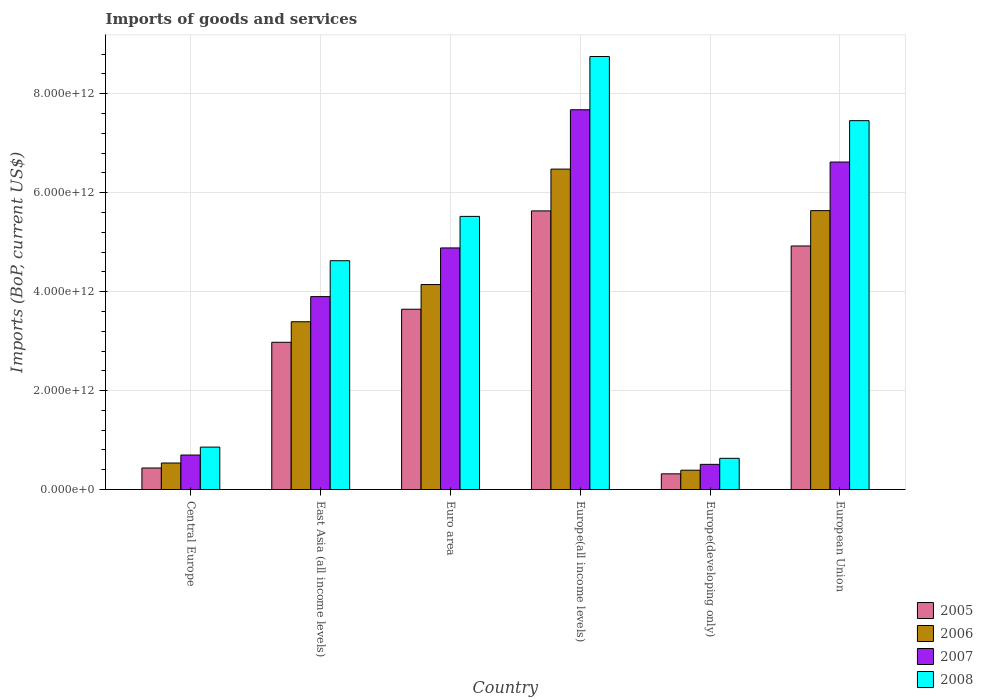How many different coloured bars are there?
Offer a very short reply. 4. How many groups of bars are there?
Your answer should be very brief. 6. Are the number of bars on each tick of the X-axis equal?
Your answer should be very brief. Yes. How many bars are there on the 5th tick from the right?
Offer a very short reply. 4. What is the label of the 2nd group of bars from the left?
Your response must be concise. East Asia (all income levels). In how many cases, is the number of bars for a given country not equal to the number of legend labels?
Keep it short and to the point. 0. What is the amount spent on imports in 2007 in Central Europe?
Provide a short and direct response. 6.97e+11. Across all countries, what is the maximum amount spent on imports in 2006?
Your answer should be very brief. 6.48e+12. Across all countries, what is the minimum amount spent on imports in 2007?
Your response must be concise. 5.09e+11. In which country was the amount spent on imports in 2008 maximum?
Keep it short and to the point. Europe(all income levels). In which country was the amount spent on imports in 2007 minimum?
Your response must be concise. Europe(developing only). What is the total amount spent on imports in 2008 in the graph?
Your answer should be compact. 2.78e+13. What is the difference between the amount spent on imports in 2007 in Europe(developing only) and that in European Union?
Make the answer very short. -6.11e+12. What is the difference between the amount spent on imports in 2008 in Europe(all income levels) and the amount spent on imports in 2005 in Euro area?
Provide a short and direct response. 5.11e+12. What is the average amount spent on imports in 2007 per country?
Offer a terse response. 4.05e+12. What is the difference between the amount spent on imports of/in 2008 and amount spent on imports of/in 2005 in Euro area?
Provide a short and direct response. 1.88e+12. In how many countries, is the amount spent on imports in 2008 greater than 4400000000000 US$?
Provide a short and direct response. 4. What is the ratio of the amount spent on imports in 2007 in East Asia (all income levels) to that in European Union?
Your answer should be very brief. 0.59. Is the amount spent on imports in 2006 in East Asia (all income levels) less than that in Europe(all income levels)?
Your answer should be compact. Yes. Is the difference between the amount spent on imports in 2008 in Euro area and Europe(developing only) greater than the difference between the amount spent on imports in 2005 in Euro area and Europe(developing only)?
Your answer should be compact. Yes. What is the difference between the highest and the second highest amount spent on imports in 2008?
Your answer should be very brief. -1.94e+12. What is the difference between the highest and the lowest amount spent on imports in 2007?
Keep it short and to the point. 7.17e+12. In how many countries, is the amount spent on imports in 2006 greater than the average amount spent on imports in 2006 taken over all countries?
Offer a very short reply. 3. Is the sum of the amount spent on imports in 2007 in Central Europe and Euro area greater than the maximum amount spent on imports in 2008 across all countries?
Make the answer very short. No. Is it the case that in every country, the sum of the amount spent on imports in 2005 and amount spent on imports in 2006 is greater than the sum of amount spent on imports in 2008 and amount spent on imports in 2007?
Offer a terse response. No. Is it the case that in every country, the sum of the amount spent on imports in 2008 and amount spent on imports in 2007 is greater than the amount spent on imports in 2006?
Ensure brevity in your answer.  Yes. What is the difference between two consecutive major ticks on the Y-axis?
Make the answer very short. 2.00e+12. Are the values on the major ticks of Y-axis written in scientific E-notation?
Make the answer very short. Yes. Does the graph contain any zero values?
Provide a succinct answer. No. Does the graph contain grids?
Offer a terse response. Yes. What is the title of the graph?
Offer a very short reply. Imports of goods and services. Does "1987" appear as one of the legend labels in the graph?
Keep it short and to the point. No. What is the label or title of the X-axis?
Offer a very short reply. Country. What is the label or title of the Y-axis?
Provide a succinct answer. Imports (BoP, current US$). What is the Imports (BoP, current US$) of 2005 in Central Europe?
Your answer should be very brief. 4.35e+11. What is the Imports (BoP, current US$) of 2006 in Central Europe?
Provide a succinct answer. 5.36e+11. What is the Imports (BoP, current US$) in 2007 in Central Europe?
Offer a very short reply. 6.97e+11. What is the Imports (BoP, current US$) of 2008 in Central Europe?
Ensure brevity in your answer.  8.57e+11. What is the Imports (BoP, current US$) of 2005 in East Asia (all income levels)?
Provide a short and direct response. 2.98e+12. What is the Imports (BoP, current US$) of 2006 in East Asia (all income levels)?
Provide a short and direct response. 3.39e+12. What is the Imports (BoP, current US$) of 2007 in East Asia (all income levels)?
Your response must be concise. 3.90e+12. What is the Imports (BoP, current US$) of 2008 in East Asia (all income levels)?
Ensure brevity in your answer.  4.63e+12. What is the Imports (BoP, current US$) in 2005 in Euro area?
Your response must be concise. 3.64e+12. What is the Imports (BoP, current US$) of 2006 in Euro area?
Offer a terse response. 4.14e+12. What is the Imports (BoP, current US$) in 2007 in Euro area?
Provide a succinct answer. 4.88e+12. What is the Imports (BoP, current US$) of 2008 in Euro area?
Ensure brevity in your answer.  5.52e+12. What is the Imports (BoP, current US$) in 2005 in Europe(all income levels)?
Keep it short and to the point. 5.63e+12. What is the Imports (BoP, current US$) in 2006 in Europe(all income levels)?
Offer a terse response. 6.48e+12. What is the Imports (BoP, current US$) in 2007 in Europe(all income levels)?
Keep it short and to the point. 7.68e+12. What is the Imports (BoP, current US$) of 2008 in Europe(all income levels)?
Ensure brevity in your answer.  8.75e+12. What is the Imports (BoP, current US$) of 2005 in Europe(developing only)?
Ensure brevity in your answer.  3.17e+11. What is the Imports (BoP, current US$) of 2006 in Europe(developing only)?
Provide a succinct answer. 3.90e+11. What is the Imports (BoP, current US$) of 2007 in Europe(developing only)?
Your answer should be compact. 5.09e+11. What is the Imports (BoP, current US$) of 2008 in Europe(developing only)?
Offer a terse response. 6.31e+11. What is the Imports (BoP, current US$) in 2005 in European Union?
Provide a short and direct response. 4.92e+12. What is the Imports (BoP, current US$) of 2006 in European Union?
Your response must be concise. 5.64e+12. What is the Imports (BoP, current US$) in 2007 in European Union?
Your answer should be compact. 6.62e+12. What is the Imports (BoP, current US$) in 2008 in European Union?
Give a very brief answer. 7.46e+12. Across all countries, what is the maximum Imports (BoP, current US$) in 2005?
Give a very brief answer. 5.63e+12. Across all countries, what is the maximum Imports (BoP, current US$) in 2006?
Keep it short and to the point. 6.48e+12. Across all countries, what is the maximum Imports (BoP, current US$) in 2007?
Offer a terse response. 7.68e+12. Across all countries, what is the maximum Imports (BoP, current US$) in 2008?
Make the answer very short. 8.75e+12. Across all countries, what is the minimum Imports (BoP, current US$) of 2005?
Ensure brevity in your answer.  3.17e+11. Across all countries, what is the minimum Imports (BoP, current US$) in 2006?
Offer a very short reply. 3.90e+11. Across all countries, what is the minimum Imports (BoP, current US$) in 2007?
Keep it short and to the point. 5.09e+11. Across all countries, what is the minimum Imports (BoP, current US$) of 2008?
Make the answer very short. 6.31e+11. What is the total Imports (BoP, current US$) in 2005 in the graph?
Provide a succinct answer. 1.79e+13. What is the total Imports (BoP, current US$) of 2006 in the graph?
Offer a very short reply. 2.06e+13. What is the total Imports (BoP, current US$) in 2007 in the graph?
Offer a terse response. 2.43e+13. What is the total Imports (BoP, current US$) in 2008 in the graph?
Ensure brevity in your answer.  2.78e+13. What is the difference between the Imports (BoP, current US$) in 2005 in Central Europe and that in East Asia (all income levels)?
Keep it short and to the point. -2.54e+12. What is the difference between the Imports (BoP, current US$) of 2006 in Central Europe and that in East Asia (all income levels)?
Ensure brevity in your answer.  -2.86e+12. What is the difference between the Imports (BoP, current US$) of 2007 in Central Europe and that in East Asia (all income levels)?
Offer a terse response. -3.20e+12. What is the difference between the Imports (BoP, current US$) in 2008 in Central Europe and that in East Asia (all income levels)?
Your answer should be compact. -3.77e+12. What is the difference between the Imports (BoP, current US$) of 2005 in Central Europe and that in Euro area?
Give a very brief answer. -3.21e+12. What is the difference between the Imports (BoP, current US$) in 2006 in Central Europe and that in Euro area?
Provide a short and direct response. -3.61e+12. What is the difference between the Imports (BoP, current US$) in 2007 in Central Europe and that in Euro area?
Offer a very short reply. -4.19e+12. What is the difference between the Imports (BoP, current US$) of 2008 in Central Europe and that in Euro area?
Your answer should be compact. -4.66e+12. What is the difference between the Imports (BoP, current US$) of 2005 in Central Europe and that in Europe(all income levels)?
Give a very brief answer. -5.20e+12. What is the difference between the Imports (BoP, current US$) in 2006 in Central Europe and that in Europe(all income levels)?
Give a very brief answer. -5.94e+12. What is the difference between the Imports (BoP, current US$) in 2007 in Central Europe and that in Europe(all income levels)?
Offer a very short reply. -6.98e+12. What is the difference between the Imports (BoP, current US$) in 2008 in Central Europe and that in Europe(all income levels)?
Offer a terse response. -7.90e+12. What is the difference between the Imports (BoP, current US$) of 2005 in Central Europe and that in Europe(developing only)?
Make the answer very short. 1.18e+11. What is the difference between the Imports (BoP, current US$) of 2006 in Central Europe and that in Europe(developing only)?
Your answer should be compact. 1.46e+11. What is the difference between the Imports (BoP, current US$) in 2007 in Central Europe and that in Europe(developing only)?
Your response must be concise. 1.88e+11. What is the difference between the Imports (BoP, current US$) of 2008 in Central Europe and that in Europe(developing only)?
Your response must be concise. 2.27e+11. What is the difference between the Imports (BoP, current US$) in 2005 in Central Europe and that in European Union?
Your answer should be very brief. -4.49e+12. What is the difference between the Imports (BoP, current US$) in 2006 in Central Europe and that in European Union?
Ensure brevity in your answer.  -5.10e+12. What is the difference between the Imports (BoP, current US$) in 2007 in Central Europe and that in European Union?
Your answer should be compact. -5.92e+12. What is the difference between the Imports (BoP, current US$) of 2008 in Central Europe and that in European Union?
Provide a succinct answer. -6.60e+12. What is the difference between the Imports (BoP, current US$) of 2005 in East Asia (all income levels) and that in Euro area?
Make the answer very short. -6.68e+11. What is the difference between the Imports (BoP, current US$) in 2006 in East Asia (all income levels) and that in Euro area?
Your answer should be compact. -7.52e+11. What is the difference between the Imports (BoP, current US$) of 2007 in East Asia (all income levels) and that in Euro area?
Keep it short and to the point. -9.84e+11. What is the difference between the Imports (BoP, current US$) of 2008 in East Asia (all income levels) and that in Euro area?
Ensure brevity in your answer.  -8.96e+11. What is the difference between the Imports (BoP, current US$) of 2005 in East Asia (all income levels) and that in Europe(all income levels)?
Ensure brevity in your answer.  -2.66e+12. What is the difference between the Imports (BoP, current US$) in 2006 in East Asia (all income levels) and that in Europe(all income levels)?
Make the answer very short. -3.09e+12. What is the difference between the Imports (BoP, current US$) in 2007 in East Asia (all income levels) and that in Europe(all income levels)?
Your response must be concise. -3.78e+12. What is the difference between the Imports (BoP, current US$) of 2008 in East Asia (all income levels) and that in Europe(all income levels)?
Give a very brief answer. -4.13e+12. What is the difference between the Imports (BoP, current US$) of 2005 in East Asia (all income levels) and that in Europe(developing only)?
Give a very brief answer. 2.66e+12. What is the difference between the Imports (BoP, current US$) of 2006 in East Asia (all income levels) and that in Europe(developing only)?
Provide a succinct answer. 3.00e+12. What is the difference between the Imports (BoP, current US$) in 2007 in East Asia (all income levels) and that in Europe(developing only)?
Your answer should be very brief. 3.39e+12. What is the difference between the Imports (BoP, current US$) of 2008 in East Asia (all income levels) and that in Europe(developing only)?
Provide a succinct answer. 3.99e+12. What is the difference between the Imports (BoP, current US$) in 2005 in East Asia (all income levels) and that in European Union?
Offer a very short reply. -1.95e+12. What is the difference between the Imports (BoP, current US$) of 2006 in East Asia (all income levels) and that in European Union?
Offer a terse response. -2.25e+12. What is the difference between the Imports (BoP, current US$) of 2007 in East Asia (all income levels) and that in European Union?
Offer a very short reply. -2.72e+12. What is the difference between the Imports (BoP, current US$) of 2008 in East Asia (all income levels) and that in European Union?
Your answer should be compact. -2.83e+12. What is the difference between the Imports (BoP, current US$) in 2005 in Euro area and that in Europe(all income levels)?
Keep it short and to the point. -1.99e+12. What is the difference between the Imports (BoP, current US$) in 2006 in Euro area and that in Europe(all income levels)?
Provide a succinct answer. -2.33e+12. What is the difference between the Imports (BoP, current US$) in 2007 in Euro area and that in Europe(all income levels)?
Your answer should be very brief. -2.79e+12. What is the difference between the Imports (BoP, current US$) of 2008 in Euro area and that in Europe(all income levels)?
Your answer should be very brief. -3.23e+12. What is the difference between the Imports (BoP, current US$) in 2005 in Euro area and that in Europe(developing only)?
Offer a very short reply. 3.33e+12. What is the difference between the Imports (BoP, current US$) in 2006 in Euro area and that in Europe(developing only)?
Give a very brief answer. 3.75e+12. What is the difference between the Imports (BoP, current US$) in 2007 in Euro area and that in Europe(developing only)?
Provide a short and direct response. 4.38e+12. What is the difference between the Imports (BoP, current US$) of 2008 in Euro area and that in Europe(developing only)?
Your answer should be very brief. 4.89e+12. What is the difference between the Imports (BoP, current US$) of 2005 in Euro area and that in European Union?
Make the answer very short. -1.28e+12. What is the difference between the Imports (BoP, current US$) in 2006 in Euro area and that in European Union?
Provide a short and direct response. -1.49e+12. What is the difference between the Imports (BoP, current US$) in 2007 in Euro area and that in European Union?
Offer a very short reply. -1.74e+12. What is the difference between the Imports (BoP, current US$) of 2008 in Euro area and that in European Union?
Give a very brief answer. -1.94e+12. What is the difference between the Imports (BoP, current US$) of 2005 in Europe(all income levels) and that in Europe(developing only)?
Your answer should be compact. 5.32e+12. What is the difference between the Imports (BoP, current US$) of 2006 in Europe(all income levels) and that in Europe(developing only)?
Provide a succinct answer. 6.09e+12. What is the difference between the Imports (BoP, current US$) of 2007 in Europe(all income levels) and that in Europe(developing only)?
Your answer should be very brief. 7.17e+12. What is the difference between the Imports (BoP, current US$) of 2008 in Europe(all income levels) and that in Europe(developing only)?
Ensure brevity in your answer.  8.12e+12. What is the difference between the Imports (BoP, current US$) in 2005 in Europe(all income levels) and that in European Union?
Ensure brevity in your answer.  7.09e+11. What is the difference between the Imports (BoP, current US$) in 2006 in Europe(all income levels) and that in European Union?
Keep it short and to the point. 8.39e+11. What is the difference between the Imports (BoP, current US$) of 2007 in Europe(all income levels) and that in European Union?
Your answer should be very brief. 1.06e+12. What is the difference between the Imports (BoP, current US$) of 2008 in Europe(all income levels) and that in European Union?
Give a very brief answer. 1.30e+12. What is the difference between the Imports (BoP, current US$) of 2005 in Europe(developing only) and that in European Union?
Give a very brief answer. -4.61e+12. What is the difference between the Imports (BoP, current US$) in 2006 in Europe(developing only) and that in European Union?
Give a very brief answer. -5.25e+12. What is the difference between the Imports (BoP, current US$) in 2007 in Europe(developing only) and that in European Union?
Offer a very short reply. -6.11e+12. What is the difference between the Imports (BoP, current US$) of 2008 in Europe(developing only) and that in European Union?
Give a very brief answer. -6.83e+12. What is the difference between the Imports (BoP, current US$) of 2005 in Central Europe and the Imports (BoP, current US$) of 2006 in East Asia (all income levels)?
Ensure brevity in your answer.  -2.96e+12. What is the difference between the Imports (BoP, current US$) of 2005 in Central Europe and the Imports (BoP, current US$) of 2007 in East Asia (all income levels)?
Ensure brevity in your answer.  -3.46e+12. What is the difference between the Imports (BoP, current US$) of 2005 in Central Europe and the Imports (BoP, current US$) of 2008 in East Asia (all income levels)?
Keep it short and to the point. -4.19e+12. What is the difference between the Imports (BoP, current US$) of 2006 in Central Europe and the Imports (BoP, current US$) of 2007 in East Asia (all income levels)?
Give a very brief answer. -3.36e+12. What is the difference between the Imports (BoP, current US$) in 2006 in Central Europe and the Imports (BoP, current US$) in 2008 in East Asia (all income levels)?
Your answer should be very brief. -4.09e+12. What is the difference between the Imports (BoP, current US$) of 2007 in Central Europe and the Imports (BoP, current US$) of 2008 in East Asia (all income levels)?
Offer a terse response. -3.93e+12. What is the difference between the Imports (BoP, current US$) of 2005 in Central Europe and the Imports (BoP, current US$) of 2006 in Euro area?
Offer a very short reply. -3.71e+12. What is the difference between the Imports (BoP, current US$) in 2005 in Central Europe and the Imports (BoP, current US$) in 2007 in Euro area?
Offer a terse response. -4.45e+12. What is the difference between the Imports (BoP, current US$) of 2005 in Central Europe and the Imports (BoP, current US$) of 2008 in Euro area?
Offer a very short reply. -5.09e+12. What is the difference between the Imports (BoP, current US$) in 2006 in Central Europe and the Imports (BoP, current US$) in 2007 in Euro area?
Ensure brevity in your answer.  -4.35e+12. What is the difference between the Imports (BoP, current US$) in 2006 in Central Europe and the Imports (BoP, current US$) in 2008 in Euro area?
Your response must be concise. -4.99e+12. What is the difference between the Imports (BoP, current US$) in 2007 in Central Europe and the Imports (BoP, current US$) in 2008 in Euro area?
Your response must be concise. -4.82e+12. What is the difference between the Imports (BoP, current US$) in 2005 in Central Europe and the Imports (BoP, current US$) in 2006 in Europe(all income levels)?
Provide a succinct answer. -6.04e+12. What is the difference between the Imports (BoP, current US$) of 2005 in Central Europe and the Imports (BoP, current US$) of 2007 in Europe(all income levels)?
Make the answer very short. -7.24e+12. What is the difference between the Imports (BoP, current US$) in 2005 in Central Europe and the Imports (BoP, current US$) in 2008 in Europe(all income levels)?
Provide a short and direct response. -8.32e+12. What is the difference between the Imports (BoP, current US$) of 2006 in Central Europe and the Imports (BoP, current US$) of 2007 in Europe(all income levels)?
Offer a very short reply. -7.14e+12. What is the difference between the Imports (BoP, current US$) of 2006 in Central Europe and the Imports (BoP, current US$) of 2008 in Europe(all income levels)?
Provide a short and direct response. -8.22e+12. What is the difference between the Imports (BoP, current US$) of 2007 in Central Europe and the Imports (BoP, current US$) of 2008 in Europe(all income levels)?
Your response must be concise. -8.06e+12. What is the difference between the Imports (BoP, current US$) of 2005 in Central Europe and the Imports (BoP, current US$) of 2006 in Europe(developing only)?
Your response must be concise. 4.49e+1. What is the difference between the Imports (BoP, current US$) in 2005 in Central Europe and the Imports (BoP, current US$) in 2007 in Europe(developing only)?
Provide a short and direct response. -7.36e+1. What is the difference between the Imports (BoP, current US$) of 2005 in Central Europe and the Imports (BoP, current US$) of 2008 in Europe(developing only)?
Make the answer very short. -1.95e+11. What is the difference between the Imports (BoP, current US$) in 2006 in Central Europe and the Imports (BoP, current US$) in 2007 in Europe(developing only)?
Make the answer very short. 2.70e+1. What is the difference between the Imports (BoP, current US$) in 2006 in Central Europe and the Imports (BoP, current US$) in 2008 in Europe(developing only)?
Your answer should be very brief. -9.48e+1. What is the difference between the Imports (BoP, current US$) in 2007 in Central Europe and the Imports (BoP, current US$) in 2008 in Europe(developing only)?
Offer a terse response. 6.65e+1. What is the difference between the Imports (BoP, current US$) in 2005 in Central Europe and the Imports (BoP, current US$) in 2006 in European Union?
Provide a succinct answer. -5.20e+12. What is the difference between the Imports (BoP, current US$) of 2005 in Central Europe and the Imports (BoP, current US$) of 2007 in European Union?
Ensure brevity in your answer.  -6.18e+12. What is the difference between the Imports (BoP, current US$) of 2005 in Central Europe and the Imports (BoP, current US$) of 2008 in European Union?
Keep it short and to the point. -7.02e+12. What is the difference between the Imports (BoP, current US$) of 2006 in Central Europe and the Imports (BoP, current US$) of 2007 in European Union?
Your response must be concise. -6.08e+12. What is the difference between the Imports (BoP, current US$) in 2006 in Central Europe and the Imports (BoP, current US$) in 2008 in European Union?
Provide a short and direct response. -6.92e+12. What is the difference between the Imports (BoP, current US$) of 2007 in Central Europe and the Imports (BoP, current US$) of 2008 in European Union?
Your answer should be very brief. -6.76e+12. What is the difference between the Imports (BoP, current US$) of 2005 in East Asia (all income levels) and the Imports (BoP, current US$) of 2006 in Euro area?
Ensure brevity in your answer.  -1.17e+12. What is the difference between the Imports (BoP, current US$) of 2005 in East Asia (all income levels) and the Imports (BoP, current US$) of 2007 in Euro area?
Your answer should be very brief. -1.91e+12. What is the difference between the Imports (BoP, current US$) in 2005 in East Asia (all income levels) and the Imports (BoP, current US$) in 2008 in Euro area?
Ensure brevity in your answer.  -2.54e+12. What is the difference between the Imports (BoP, current US$) in 2006 in East Asia (all income levels) and the Imports (BoP, current US$) in 2007 in Euro area?
Provide a short and direct response. -1.49e+12. What is the difference between the Imports (BoP, current US$) in 2006 in East Asia (all income levels) and the Imports (BoP, current US$) in 2008 in Euro area?
Offer a very short reply. -2.13e+12. What is the difference between the Imports (BoP, current US$) of 2007 in East Asia (all income levels) and the Imports (BoP, current US$) of 2008 in Euro area?
Your answer should be very brief. -1.62e+12. What is the difference between the Imports (BoP, current US$) in 2005 in East Asia (all income levels) and the Imports (BoP, current US$) in 2006 in Europe(all income levels)?
Make the answer very short. -3.50e+12. What is the difference between the Imports (BoP, current US$) in 2005 in East Asia (all income levels) and the Imports (BoP, current US$) in 2007 in Europe(all income levels)?
Offer a very short reply. -4.70e+12. What is the difference between the Imports (BoP, current US$) of 2005 in East Asia (all income levels) and the Imports (BoP, current US$) of 2008 in Europe(all income levels)?
Provide a short and direct response. -5.78e+12. What is the difference between the Imports (BoP, current US$) of 2006 in East Asia (all income levels) and the Imports (BoP, current US$) of 2007 in Europe(all income levels)?
Your answer should be compact. -4.29e+12. What is the difference between the Imports (BoP, current US$) of 2006 in East Asia (all income levels) and the Imports (BoP, current US$) of 2008 in Europe(all income levels)?
Provide a short and direct response. -5.36e+12. What is the difference between the Imports (BoP, current US$) of 2007 in East Asia (all income levels) and the Imports (BoP, current US$) of 2008 in Europe(all income levels)?
Your answer should be compact. -4.85e+12. What is the difference between the Imports (BoP, current US$) in 2005 in East Asia (all income levels) and the Imports (BoP, current US$) in 2006 in Europe(developing only)?
Offer a very short reply. 2.59e+12. What is the difference between the Imports (BoP, current US$) of 2005 in East Asia (all income levels) and the Imports (BoP, current US$) of 2007 in Europe(developing only)?
Offer a very short reply. 2.47e+12. What is the difference between the Imports (BoP, current US$) of 2005 in East Asia (all income levels) and the Imports (BoP, current US$) of 2008 in Europe(developing only)?
Your response must be concise. 2.35e+12. What is the difference between the Imports (BoP, current US$) in 2006 in East Asia (all income levels) and the Imports (BoP, current US$) in 2007 in Europe(developing only)?
Ensure brevity in your answer.  2.88e+12. What is the difference between the Imports (BoP, current US$) of 2006 in East Asia (all income levels) and the Imports (BoP, current US$) of 2008 in Europe(developing only)?
Provide a succinct answer. 2.76e+12. What is the difference between the Imports (BoP, current US$) in 2007 in East Asia (all income levels) and the Imports (BoP, current US$) in 2008 in Europe(developing only)?
Keep it short and to the point. 3.27e+12. What is the difference between the Imports (BoP, current US$) in 2005 in East Asia (all income levels) and the Imports (BoP, current US$) in 2006 in European Union?
Ensure brevity in your answer.  -2.66e+12. What is the difference between the Imports (BoP, current US$) in 2005 in East Asia (all income levels) and the Imports (BoP, current US$) in 2007 in European Union?
Offer a very short reply. -3.64e+12. What is the difference between the Imports (BoP, current US$) in 2005 in East Asia (all income levels) and the Imports (BoP, current US$) in 2008 in European Union?
Give a very brief answer. -4.48e+12. What is the difference between the Imports (BoP, current US$) of 2006 in East Asia (all income levels) and the Imports (BoP, current US$) of 2007 in European Union?
Offer a very short reply. -3.23e+12. What is the difference between the Imports (BoP, current US$) in 2006 in East Asia (all income levels) and the Imports (BoP, current US$) in 2008 in European Union?
Keep it short and to the point. -4.06e+12. What is the difference between the Imports (BoP, current US$) in 2007 in East Asia (all income levels) and the Imports (BoP, current US$) in 2008 in European Union?
Provide a short and direct response. -3.56e+12. What is the difference between the Imports (BoP, current US$) of 2005 in Euro area and the Imports (BoP, current US$) of 2006 in Europe(all income levels)?
Offer a terse response. -2.83e+12. What is the difference between the Imports (BoP, current US$) in 2005 in Euro area and the Imports (BoP, current US$) in 2007 in Europe(all income levels)?
Keep it short and to the point. -4.03e+12. What is the difference between the Imports (BoP, current US$) of 2005 in Euro area and the Imports (BoP, current US$) of 2008 in Europe(all income levels)?
Make the answer very short. -5.11e+12. What is the difference between the Imports (BoP, current US$) of 2006 in Euro area and the Imports (BoP, current US$) of 2007 in Europe(all income levels)?
Provide a succinct answer. -3.53e+12. What is the difference between the Imports (BoP, current US$) in 2006 in Euro area and the Imports (BoP, current US$) in 2008 in Europe(all income levels)?
Provide a succinct answer. -4.61e+12. What is the difference between the Imports (BoP, current US$) in 2007 in Euro area and the Imports (BoP, current US$) in 2008 in Europe(all income levels)?
Your answer should be very brief. -3.87e+12. What is the difference between the Imports (BoP, current US$) in 2005 in Euro area and the Imports (BoP, current US$) in 2006 in Europe(developing only)?
Offer a very short reply. 3.25e+12. What is the difference between the Imports (BoP, current US$) in 2005 in Euro area and the Imports (BoP, current US$) in 2007 in Europe(developing only)?
Provide a succinct answer. 3.14e+12. What is the difference between the Imports (BoP, current US$) in 2005 in Euro area and the Imports (BoP, current US$) in 2008 in Europe(developing only)?
Offer a very short reply. 3.01e+12. What is the difference between the Imports (BoP, current US$) of 2006 in Euro area and the Imports (BoP, current US$) of 2007 in Europe(developing only)?
Ensure brevity in your answer.  3.63e+12. What is the difference between the Imports (BoP, current US$) of 2006 in Euro area and the Imports (BoP, current US$) of 2008 in Europe(developing only)?
Provide a succinct answer. 3.51e+12. What is the difference between the Imports (BoP, current US$) in 2007 in Euro area and the Imports (BoP, current US$) in 2008 in Europe(developing only)?
Your response must be concise. 4.25e+12. What is the difference between the Imports (BoP, current US$) of 2005 in Euro area and the Imports (BoP, current US$) of 2006 in European Union?
Keep it short and to the point. -1.99e+12. What is the difference between the Imports (BoP, current US$) of 2005 in Euro area and the Imports (BoP, current US$) of 2007 in European Union?
Keep it short and to the point. -2.98e+12. What is the difference between the Imports (BoP, current US$) of 2005 in Euro area and the Imports (BoP, current US$) of 2008 in European Union?
Offer a very short reply. -3.81e+12. What is the difference between the Imports (BoP, current US$) in 2006 in Euro area and the Imports (BoP, current US$) in 2007 in European Union?
Your answer should be compact. -2.48e+12. What is the difference between the Imports (BoP, current US$) of 2006 in Euro area and the Imports (BoP, current US$) of 2008 in European Union?
Keep it short and to the point. -3.31e+12. What is the difference between the Imports (BoP, current US$) in 2007 in Euro area and the Imports (BoP, current US$) in 2008 in European Union?
Your response must be concise. -2.57e+12. What is the difference between the Imports (BoP, current US$) of 2005 in Europe(all income levels) and the Imports (BoP, current US$) of 2006 in Europe(developing only)?
Provide a succinct answer. 5.24e+12. What is the difference between the Imports (BoP, current US$) of 2005 in Europe(all income levels) and the Imports (BoP, current US$) of 2007 in Europe(developing only)?
Provide a short and direct response. 5.12e+12. What is the difference between the Imports (BoP, current US$) of 2005 in Europe(all income levels) and the Imports (BoP, current US$) of 2008 in Europe(developing only)?
Your answer should be very brief. 5.00e+12. What is the difference between the Imports (BoP, current US$) of 2006 in Europe(all income levels) and the Imports (BoP, current US$) of 2007 in Europe(developing only)?
Offer a very short reply. 5.97e+12. What is the difference between the Imports (BoP, current US$) in 2006 in Europe(all income levels) and the Imports (BoP, current US$) in 2008 in Europe(developing only)?
Give a very brief answer. 5.85e+12. What is the difference between the Imports (BoP, current US$) in 2007 in Europe(all income levels) and the Imports (BoP, current US$) in 2008 in Europe(developing only)?
Keep it short and to the point. 7.05e+12. What is the difference between the Imports (BoP, current US$) in 2005 in Europe(all income levels) and the Imports (BoP, current US$) in 2006 in European Union?
Keep it short and to the point. -5.36e+09. What is the difference between the Imports (BoP, current US$) in 2005 in Europe(all income levels) and the Imports (BoP, current US$) in 2007 in European Union?
Provide a succinct answer. -9.88e+11. What is the difference between the Imports (BoP, current US$) in 2005 in Europe(all income levels) and the Imports (BoP, current US$) in 2008 in European Union?
Provide a short and direct response. -1.82e+12. What is the difference between the Imports (BoP, current US$) in 2006 in Europe(all income levels) and the Imports (BoP, current US$) in 2007 in European Union?
Ensure brevity in your answer.  -1.43e+11. What is the difference between the Imports (BoP, current US$) in 2006 in Europe(all income levels) and the Imports (BoP, current US$) in 2008 in European Union?
Offer a very short reply. -9.79e+11. What is the difference between the Imports (BoP, current US$) in 2007 in Europe(all income levels) and the Imports (BoP, current US$) in 2008 in European Union?
Make the answer very short. 2.20e+11. What is the difference between the Imports (BoP, current US$) in 2005 in Europe(developing only) and the Imports (BoP, current US$) in 2006 in European Union?
Offer a very short reply. -5.32e+12. What is the difference between the Imports (BoP, current US$) in 2005 in Europe(developing only) and the Imports (BoP, current US$) in 2007 in European Union?
Provide a succinct answer. -6.30e+12. What is the difference between the Imports (BoP, current US$) in 2005 in Europe(developing only) and the Imports (BoP, current US$) in 2008 in European Union?
Keep it short and to the point. -7.14e+12. What is the difference between the Imports (BoP, current US$) in 2006 in Europe(developing only) and the Imports (BoP, current US$) in 2007 in European Union?
Your response must be concise. -6.23e+12. What is the difference between the Imports (BoP, current US$) in 2006 in Europe(developing only) and the Imports (BoP, current US$) in 2008 in European Union?
Make the answer very short. -7.07e+12. What is the difference between the Imports (BoP, current US$) in 2007 in Europe(developing only) and the Imports (BoP, current US$) in 2008 in European Union?
Offer a terse response. -6.95e+12. What is the average Imports (BoP, current US$) in 2005 per country?
Ensure brevity in your answer.  2.99e+12. What is the average Imports (BoP, current US$) of 2006 per country?
Provide a short and direct response. 3.43e+12. What is the average Imports (BoP, current US$) of 2007 per country?
Your answer should be very brief. 4.05e+12. What is the average Imports (BoP, current US$) of 2008 per country?
Ensure brevity in your answer.  4.64e+12. What is the difference between the Imports (BoP, current US$) of 2005 and Imports (BoP, current US$) of 2006 in Central Europe?
Offer a very short reply. -1.01e+11. What is the difference between the Imports (BoP, current US$) of 2005 and Imports (BoP, current US$) of 2007 in Central Europe?
Your answer should be compact. -2.62e+11. What is the difference between the Imports (BoP, current US$) of 2005 and Imports (BoP, current US$) of 2008 in Central Europe?
Your response must be concise. -4.22e+11. What is the difference between the Imports (BoP, current US$) of 2006 and Imports (BoP, current US$) of 2007 in Central Europe?
Give a very brief answer. -1.61e+11. What is the difference between the Imports (BoP, current US$) in 2006 and Imports (BoP, current US$) in 2008 in Central Europe?
Your answer should be compact. -3.22e+11. What is the difference between the Imports (BoP, current US$) in 2007 and Imports (BoP, current US$) in 2008 in Central Europe?
Provide a short and direct response. -1.60e+11. What is the difference between the Imports (BoP, current US$) of 2005 and Imports (BoP, current US$) of 2006 in East Asia (all income levels)?
Provide a short and direct response. -4.15e+11. What is the difference between the Imports (BoP, current US$) of 2005 and Imports (BoP, current US$) of 2007 in East Asia (all income levels)?
Offer a terse response. -9.23e+11. What is the difference between the Imports (BoP, current US$) of 2005 and Imports (BoP, current US$) of 2008 in East Asia (all income levels)?
Offer a terse response. -1.65e+12. What is the difference between the Imports (BoP, current US$) of 2006 and Imports (BoP, current US$) of 2007 in East Asia (all income levels)?
Your response must be concise. -5.08e+11. What is the difference between the Imports (BoP, current US$) in 2006 and Imports (BoP, current US$) in 2008 in East Asia (all income levels)?
Your answer should be very brief. -1.23e+12. What is the difference between the Imports (BoP, current US$) of 2007 and Imports (BoP, current US$) of 2008 in East Asia (all income levels)?
Offer a terse response. -7.26e+11. What is the difference between the Imports (BoP, current US$) in 2005 and Imports (BoP, current US$) in 2006 in Euro area?
Provide a short and direct response. -4.99e+11. What is the difference between the Imports (BoP, current US$) in 2005 and Imports (BoP, current US$) in 2007 in Euro area?
Make the answer very short. -1.24e+12. What is the difference between the Imports (BoP, current US$) in 2005 and Imports (BoP, current US$) in 2008 in Euro area?
Give a very brief answer. -1.88e+12. What is the difference between the Imports (BoP, current US$) in 2006 and Imports (BoP, current US$) in 2007 in Euro area?
Offer a very short reply. -7.41e+11. What is the difference between the Imports (BoP, current US$) in 2006 and Imports (BoP, current US$) in 2008 in Euro area?
Your answer should be very brief. -1.38e+12. What is the difference between the Imports (BoP, current US$) of 2007 and Imports (BoP, current US$) of 2008 in Euro area?
Offer a terse response. -6.37e+11. What is the difference between the Imports (BoP, current US$) of 2005 and Imports (BoP, current US$) of 2006 in Europe(all income levels)?
Offer a very short reply. -8.45e+11. What is the difference between the Imports (BoP, current US$) of 2005 and Imports (BoP, current US$) of 2007 in Europe(all income levels)?
Your response must be concise. -2.04e+12. What is the difference between the Imports (BoP, current US$) in 2005 and Imports (BoP, current US$) in 2008 in Europe(all income levels)?
Your response must be concise. -3.12e+12. What is the difference between the Imports (BoP, current US$) of 2006 and Imports (BoP, current US$) of 2007 in Europe(all income levels)?
Make the answer very short. -1.20e+12. What is the difference between the Imports (BoP, current US$) of 2006 and Imports (BoP, current US$) of 2008 in Europe(all income levels)?
Your answer should be very brief. -2.28e+12. What is the difference between the Imports (BoP, current US$) of 2007 and Imports (BoP, current US$) of 2008 in Europe(all income levels)?
Offer a terse response. -1.08e+12. What is the difference between the Imports (BoP, current US$) in 2005 and Imports (BoP, current US$) in 2006 in Europe(developing only)?
Your answer should be compact. -7.33e+1. What is the difference between the Imports (BoP, current US$) of 2005 and Imports (BoP, current US$) of 2007 in Europe(developing only)?
Provide a succinct answer. -1.92e+11. What is the difference between the Imports (BoP, current US$) in 2005 and Imports (BoP, current US$) in 2008 in Europe(developing only)?
Your response must be concise. -3.14e+11. What is the difference between the Imports (BoP, current US$) in 2006 and Imports (BoP, current US$) in 2007 in Europe(developing only)?
Your response must be concise. -1.18e+11. What is the difference between the Imports (BoP, current US$) in 2006 and Imports (BoP, current US$) in 2008 in Europe(developing only)?
Offer a very short reply. -2.40e+11. What is the difference between the Imports (BoP, current US$) of 2007 and Imports (BoP, current US$) of 2008 in Europe(developing only)?
Provide a succinct answer. -1.22e+11. What is the difference between the Imports (BoP, current US$) in 2005 and Imports (BoP, current US$) in 2006 in European Union?
Provide a succinct answer. -7.15e+11. What is the difference between the Imports (BoP, current US$) in 2005 and Imports (BoP, current US$) in 2007 in European Union?
Make the answer very short. -1.70e+12. What is the difference between the Imports (BoP, current US$) in 2005 and Imports (BoP, current US$) in 2008 in European Union?
Your answer should be very brief. -2.53e+12. What is the difference between the Imports (BoP, current US$) of 2006 and Imports (BoP, current US$) of 2007 in European Union?
Keep it short and to the point. -9.82e+11. What is the difference between the Imports (BoP, current US$) in 2006 and Imports (BoP, current US$) in 2008 in European Union?
Make the answer very short. -1.82e+12. What is the difference between the Imports (BoP, current US$) in 2007 and Imports (BoP, current US$) in 2008 in European Union?
Keep it short and to the point. -8.37e+11. What is the ratio of the Imports (BoP, current US$) of 2005 in Central Europe to that in East Asia (all income levels)?
Make the answer very short. 0.15. What is the ratio of the Imports (BoP, current US$) of 2006 in Central Europe to that in East Asia (all income levels)?
Ensure brevity in your answer.  0.16. What is the ratio of the Imports (BoP, current US$) in 2007 in Central Europe to that in East Asia (all income levels)?
Your answer should be compact. 0.18. What is the ratio of the Imports (BoP, current US$) in 2008 in Central Europe to that in East Asia (all income levels)?
Offer a terse response. 0.19. What is the ratio of the Imports (BoP, current US$) of 2005 in Central Europe to that in Euro area?
Give a very brief answer. 0.12. What is the ratio of the Imports (BoP, current US$) of 2006 in Central Europe to that in Euro area?
Your answer should be very brief. 0.13. What is the ratio of the Imports (BoP, current US$) in 2007 in Central Europe to that in Euro area?
Offer a terse response. 0.14. What is the ratio of the Imports (BoP, current US$) of 2008 in Central Europe to that in Euro area?
Your answer should be very brief. 0.16. What is the ratio of the Imports (BoP, current US$) of 2005 in Central Europe to that in Europe(all income levels)?
Provide a short and direct response. 0.08. What is the ratio of the Imports (BoP, current US$) in 2006 in Central Europe to that in Europe(all income levels)?
Give a very brief answer. 0.08. What is the ratio of the Imports (BoP, current US$) of 2007 in Central Europe to that in Europe(all income levels)?
Make the answer very short. 0.09. What is the ratio of the Imports (BoP, current US$) of 2008 in Central Europe to that in Europe(all income levels)?
Keep it short and to the point. 0.1. What is the ratio of the Imports (BoP, current US$) of 2005 in Central Europe to that in Europe(developing only)?
Your response must be concise. 1.37. What is the ratio of the Imports (BoP, current US$) in 2006 in Central Europe to that in Europe(developing only)?
Provide a short and direct response. 1.37. What is the ratio of the Imports (BoP, current US$) of 2007 in Central Europe to that in Europe(developing only)?
Make the answer very short. 1.37. What is the ratio of the Imports (BoP, current US$) of 2008 in Central Europe to that in Europe(developing only)?
Your response must be concise. 1.36. What is the ratio of the Imports (BoP, current US$) of 2005 in Central Europe to that in European Union?
Provide a succinct answer. 0.09. What is the ratio of the Imports (BoP, current US$) of 2006 in Central Europe to that in European Union?
Provide a short and direct response. 0.1. What is the ratio of the Imports (BoP, current US$) of 2007 in Central Europe to that in European Union?
Your answer should be very brief. 0.11. What is the ratio of the Imports (BoP, current US$) in 2008 in Central Europe to that in European Union?
Ensure brevity in your answer.  0.12. What is the ratio of the Imports (BoP, current US$) of 2005 in East Asia (all income levels) to that in Euro area?
Ensure brevity in your answer.  0.82. What is the ratio of the Imports (BoP, current US$) in 2006 in East Asia (all income levels) to that in Euro area?
Your response must be concise. 0.82. What is the ratio of the Imports (BoP, current US$) in 2007 in East Asia (all income levels) to that in Euro area?
Make the answer very short. 0.8. What is the ratio of the Imports (BoP, current US$) of 2008 in East Asia (all income levels) to that in Euro area?
Ensure brevity in your answer.  0.84. What is the ratio of the Imports (BoP, current US$) of 2005 in East Asia (all income levels) to that in Europe(all income levels)?
Your response must be concise. 0.53. What is the ratio of the Imports (BoP, current US$) in 2006 in East Asia (all income levels) to that in Europe(all income levels)?
Provide a succinct answer. 0.52. What is the ratio of the Imports (BoP, current US$) in 2007 in East Asia (all income levels) to that in Europe(all income levels)?
Provide a succinct answer. 0.51. What is the ratio of the Imports (BoP, current US$) in 2008 in East Asia (all income levels) to that in Europe(all income levels)?
Keep it short and to the point. 0.53. What is the ratio of the Imports (BoP, current US$) of 2005 in East Asia (all income levels) to that in Europe(developing only)?
Give a very brief answer. 9.39. What is the ratio of the Imports (BoP, current US$) in 2006 in East Asia (all income levels) to that in Europe(developing only)?
Keep it short and to the point. 8.69. What is the ratio of the Imports (BoP, current US$) in 2007 in East Asia (all income levels) to that in Europe(developing only)?
Offer a terse response. 7.66. What is the ratio of the Imports (BoP, current US$) in 2008 in East Asia (all income levels) to that in Europe(developing only)?
Your response must be concise. 7.34. What is the ratio of the Imports (BoP, current US$) of 2005 in East Asia (all income levels) to that in European Union?
Offer a terse response. 0.6. What is the ratio of the Imports (BoP, current US$) in 2006 in East Asia (all income levels) to that in European Union?
Keep it short and to the point. 0.6. What is the ratio of the Imports (BoP, current US$) in 2007 in East Asia (all income levels) to that in European Union?
Make the answer very short. 0.59. What is the ratio of the Imports (BoP, current US$) in 2008 in East Asia (all income levels) to that in European Union?
Your response must be concise. 0.62. What is the ratio of the Imports (BoP, current US$) in 2005 in Euro area to that in Europe(all income levels)?
Provide a succinct answer. 0.65. What is the ratio of the Imports (BoP, current US$) of 2006 in Euro area to that in Europe(all income levels)?
Offer a very short reply. 0.64. What is the ratio of the Imports (BoP, current US$) of 2007 in Euro area to that in Europe(all income levels)?
Provide a succinct answer. 0.64. What is the ratio of the Imports (BoP, current US$) of 2008 in Euro area to that in Europe(all income levels)?
Your answer should be very brief. 0.63. What is the ratio of the Imports (BoP, current US$) of 2005 in Euro area to that in Europe(developing only)?
Your answer should be very brief. 11.5. What is the ratio of the Imports (BoP, current US$) in 2006 in Euro area to that in Europe(developing only)?
Ensure brevity in your answer.  10.62. What is the ratio of the Imports (BoP, current US$) of 2007 in Euro area to that in Europe(developing only)?
Keep it short and to the point. 9.6. What is the ratio of the Imports (BoP, current US$) in 2008 in Euro area to that in Europe(developing only)?
Provide a succinct answer. 8.76. What is the ratio of the Imports (BoP, current US$) of 2005 in Euro area to that in European Union?
Offer a terse response. 0.74. What is the ratio of the Imports (BoP, current US$) of 2006 in Euro area to that in European Union?
Offer a terse response. 0.73. What is the ratio of the Imports (BoP, current US$) in 2007 in Euro area to that in European Union?
Your answer should be compact. 0.74. What is the ratio of the Imports (BoP, current US$) in 2008 in Euro area to that in European Union?
Make the answer very short. 0.74. What is the ratio of the Imports (BoP, current US$) of 2005 in Europe(all income levels) to that in Europe(developing only)?
Your answer should be compact. 17.77. What is the ratio of the Imports (BoP, current US$) in 2006 in Europe(all income levels) to that in Europe(developing only)?
Your answer should be very brief. 16.6. What is the ratio of the Imports (BoP, current US$) of 2007 in Europe(all income levels) to that in Europe(developing only)?
Offer a terse response. 15.09. What is the ratio of the Imports (BoP, current US$) of 2008 in Europe(all income levels) to that in Europe(developing only)?
Give a very brief answer. 13.88. What is the ratio of the Imports (BoP, current US$) in 2005 in Europe(all income levels) to that in European Union?
Ensure brevity in your answer.  1.14. What is the ratio of the Imports (BoP, current US$) in 2006 in Europe(all income levels) to that in European Union?
Your response must be concise. 1.15. What is the ratio of the Imports (BoP, current US$) of 2007 in Europe(all income levels) to that in European Union?
Offer a terse response. 1.16. What is the ratio of the Imports (BoP, current US$) of 2008 in Europe(all income levels) to that in European Union?
Offer a terse response. 1.17. What is the ratio of the Imports (BoP, current US$) of 2005 in Europe(developing only) to that in European Union?
Keep it short and to the point. 0.06. What is the ratio of the Imports (BoP, current US$) in 2006 in Europe(developing only) to that in European Union?
Provide a succinct answer. 0.07. What is the ratio of the Imports (BoP, current US$) in 2007 in Europe(developing only) to that in European Union?
Make the answer very short. 0.08. What is the ratio of the Imports (BoP, current US$) of 2008 in Europe(developing only) to that in European Union?
Make the answer very short. 0.08. What is the difference between the highest and the second highest Imports (BoP, current US$) of 2005?
Provide a short and direct response. 7.09e+11. What is the difference between the highest and the second highest Imports (BoP, current US$) in 2006?
Make the answer very short. 8.39e+11. What is the difference between the highest and the second highest Imports (BoP, current US$) in 2007?
Offer a terse response. 1.06e+12. What is the difference between the highest and the second highest Imports (BoP, current US$) of 2008?
Offer a very short reply. 1.30e+12. What is the difference between the highest and the lowest Imports (BoP, current US$) in 2005?
Provide a succinct answer. 5.32e+12. What is the difference between the highest and the lowest Imports (BoP, current US$) of 2006?
Offer a terse response. 6.09e+12. What is the difference between the highest and the lowest Imports (BoP, current US$) of 2007?
Your answer should be compact. 7.17e+12. What is the difference between the highest and the lowest Imports (BoP, current US$) of 2008?
Offer a terse response. 8.12e+12. 